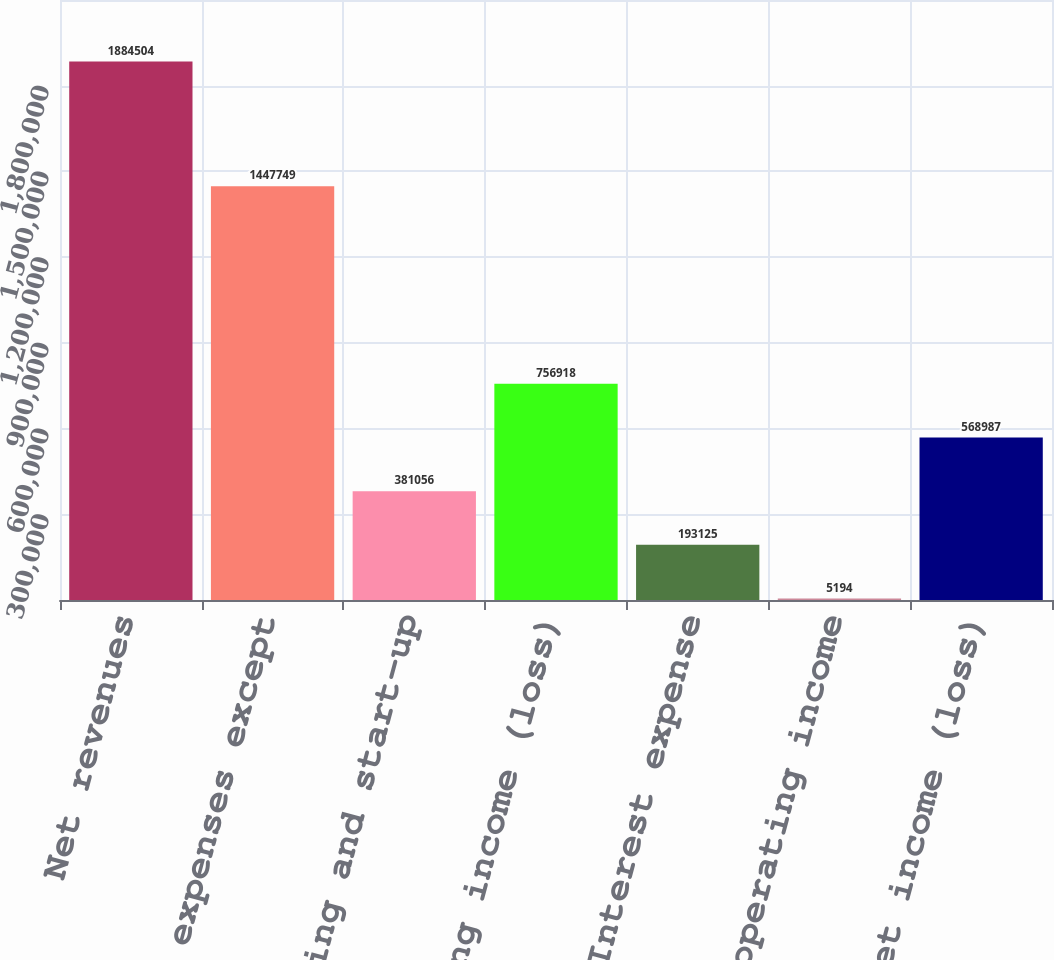Convert chart to OTSL. <chart><loc_0><loc_0><loc_500><loc_500><bar_chart><fcel>Net revenues<fcel>Operating expenses except<fcel>Preopening and start-up<fcel>Operating income (loss)<fcel>Interest expense<fcel>Other non-operating income<fcel>Net income (loss)<nl><fcel>1.8845e+06<fcel>1.44775e+06<fcel>381056<fcel>756918<fcel>193125<fcel>5194<fcel>568987<nl></chart> 